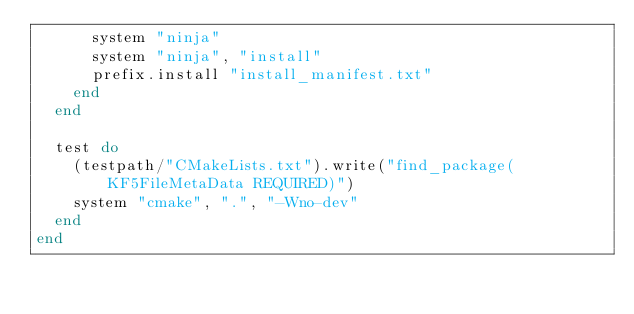Convert code to text. <code><loc_0><loc_0><loc_500><loc_500><_Ruby_>      system "ninja"
      system "ninja", "install"
      prefix.install "install_manifest.txt"
    end
  end

  test do
    (testpath/"CMakeLists.txt").write("find_package(KF5FileMetaData REQUIRED)")
    system "cmake", ".", "-Wno-dev"
  end
end
</code> 